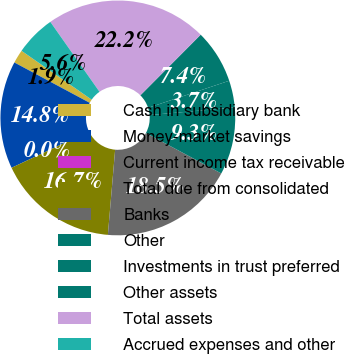Convert chart. <chart><loc_0><loc_0><loc_500><loc_500><pie_chart><fcel>Cash in subsidiary bank<fcel>Money-market savings<fcel>Current income tax receivable<fcel>Total due from consolidated<fcel>Banks<fcel>Other<fcel>Investments in trust preferred<fcel>Other assets<fcel>Total assets<fcel>Accrued expenses and other<nl><fcel>1.86%<fcel>14.81%<fcel>0.0%<fcel>16.66%<fcel>18.51%<fcel>9.26%<fcel>3.71%<fcel>7.41%<fcel>22.22%<fcel>5.56%<nl></chart> 